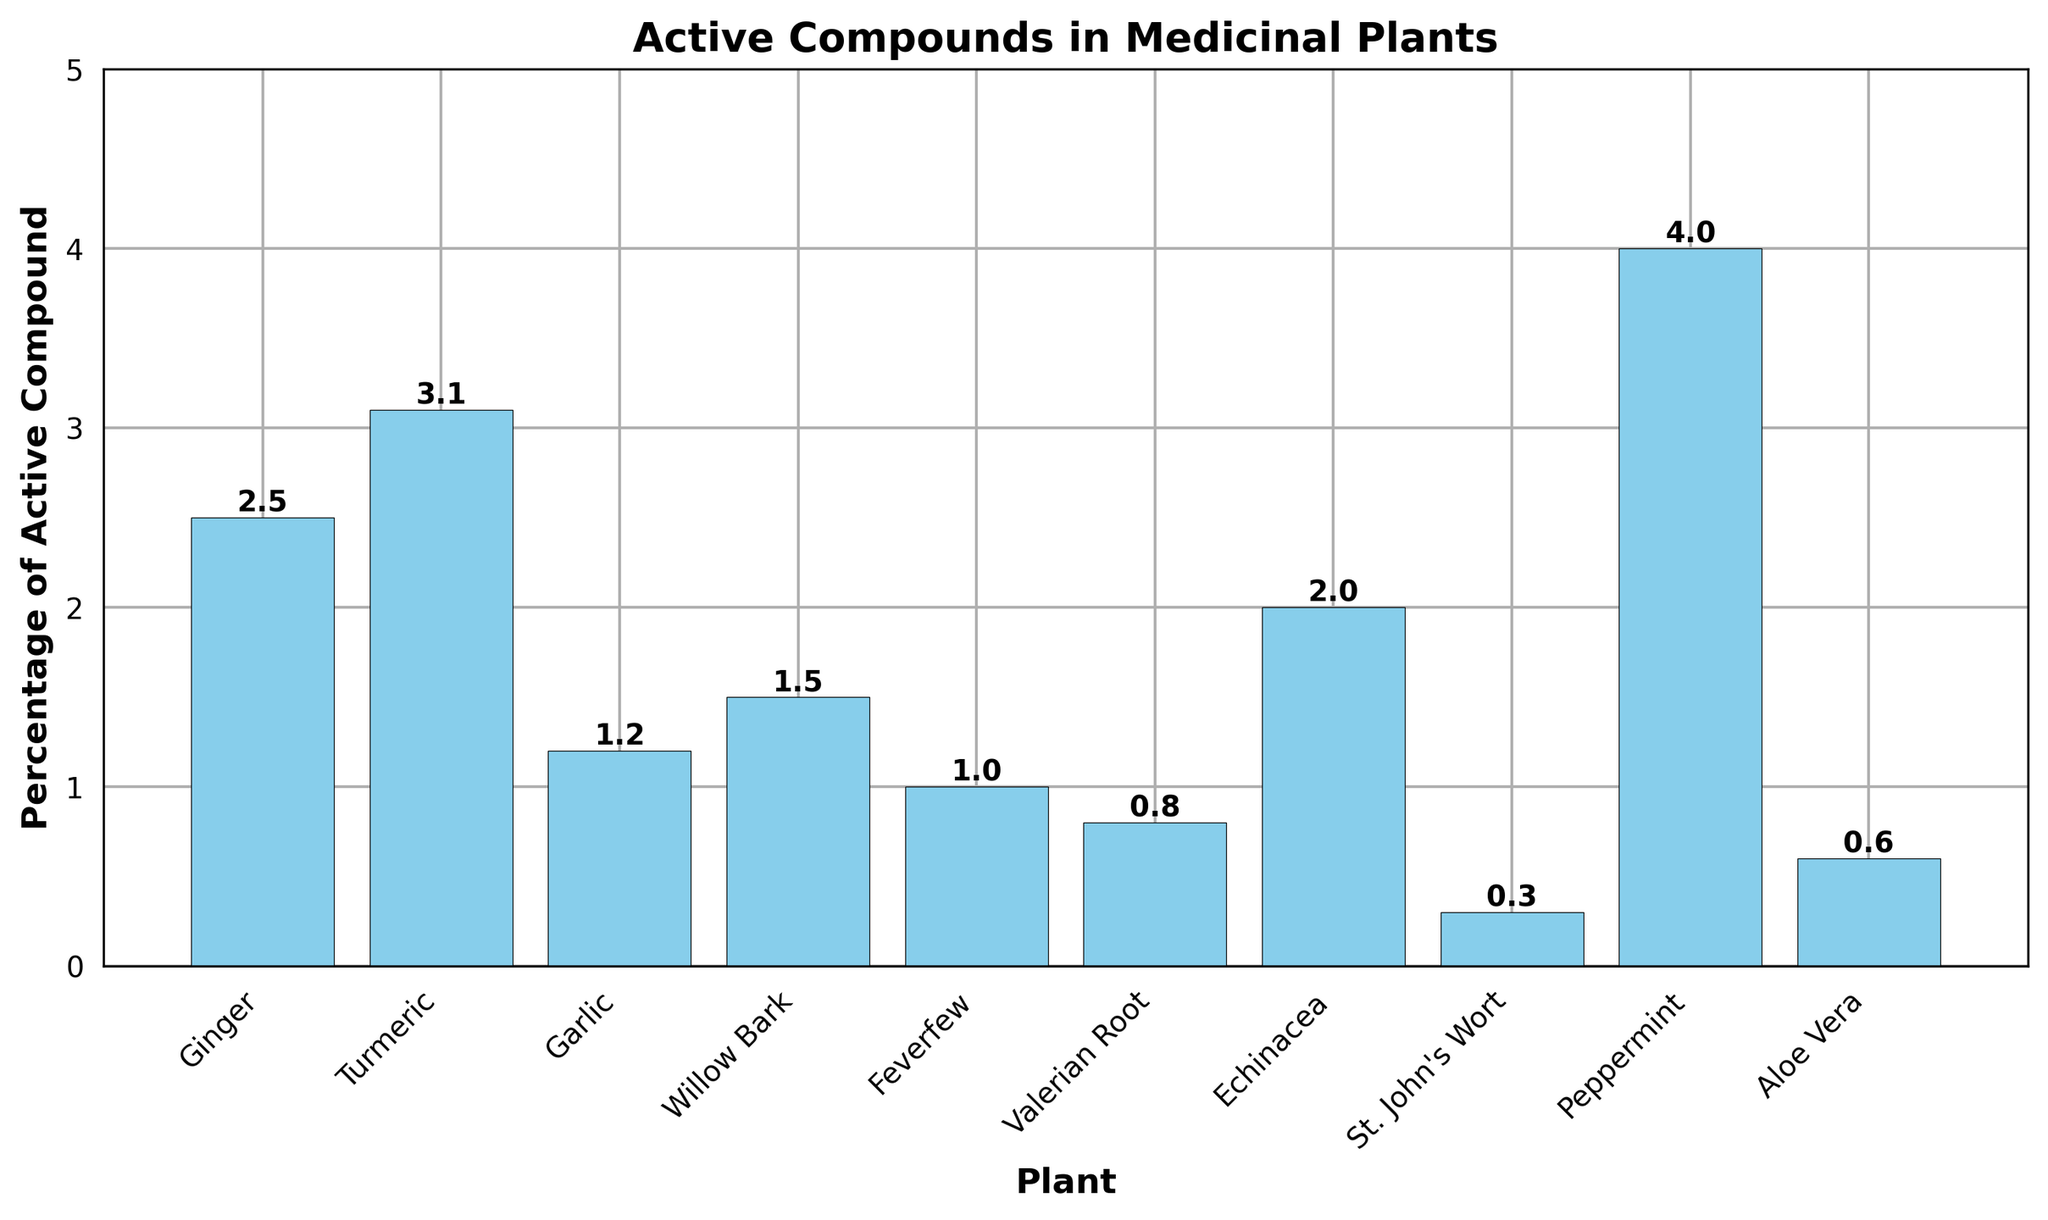Which plant has the highest percentage of active compounds? To determine the plant with the highest percentage of active compounds, look for the tallest bar on the chart. The tallest bar corresponds to Peppermint, which has 4.0%.
Answer: Peppermint How much higher is the percentage of Curcumin in Turmeric compared to Allicin in Garlic? Identify the bars for Turmeric (3.1%) and Garlic (1.2%). Subtract the percentage of Allicin in Garlic from the percentage of Curcumin in Turmeric (3.1% - 1.2% = 1.9%).
Answer: 1.9% What is the total percentage of active compounds in Ginger, Echinacea, and Aloe Vera? Identify the bars for Ginger (2.5%), Echinacea (2.0%), and Aloe Vera (0.6%). Add these percentages together: 2.5% + 2.0% + 0.6% = 5.1%.
Answer: 5.1% Is the percentage of Gingerol in Ginger greater than the percentage of Curcumin in Turmeric? Compare the heights of the bars for Ginger and Turmeric. Ginger contains 2.5% Gingerol, while Turmeric contains 3.1% Curcumin. 2.5% is less than 3.1%.
Answer: No Which plant has the lowest percentage of active compounds, and what is that percentage? Identify the shortest bar on the chart. The shortest bar corresponds to St. John's Wort, which has 0.3% Hypericin.
Answer: St. John's Wort, 0.3% Calculate the average percentage of active compounds across all plants. Sum all the percentages and divide by the number of plants. (2.5 + 3.1 + 1.2 + 1.5 + 1.0 + 0.8 + 2.0 + 0.3 + 4.0 + 0.6) / 10 = 17.0 / 10 = 1.7%.
Answer: 1.7% How does the percentage of Salicin in Willow Bark compare to the percentage of Menthol in Peppermint? Identify the bars for Willow Bark (1.5%) and Peppermint (4.0%). Compare 1.5% with 4.0%. 1.5% is less than 4.0%.
Answer: Less What is the difference in percentage points between the highest and lowest percentages of active compounds? Find the highest percentage (Peppermint, 4.0%) and the lowest percentage (St. John's Wort, 0.3%). Subtract the lowest from the highest (4.0% - 0.3% = 3.7%).
Answer: 3.7% What percentage of active compounds does Feverfew contain, and how does it visually compare to Valerian Root on the chart? Identify the bars for Feverfew (1.0%) and Valerian Root (0.8%). Feverfew has a slightly higher bar with a percentage of 1.0% compared to Valerian Root's 0.8%.
Answer: 1.0%, slightly higher 